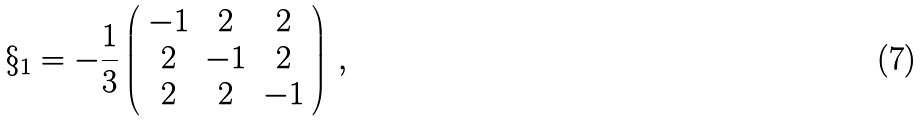Convert formula to latex. <formula><loc_0><loc_0><loc_500><loc_500>\S _ { 1 } = - \frac { 1 } { 3 } \left ( \begin{array} { c c c } - 1 & 2 & 2 \\ 2 & - 1 & 2 \\ 2 & 2 & - 1 \end{array} \right ) \, ,</formula> 